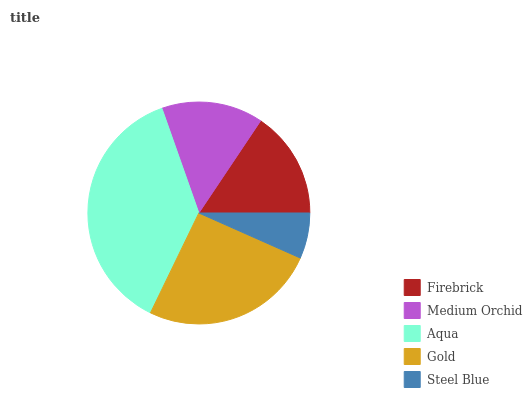Is Steel Blue the minimum?
Answer yes or no. Yes. Is Aqua the maximum?
Answer yes or no. Yes. Is Medium Orchid the minimum?
Answer yes or no. No. Is Medium Orchid the maximum?
Answer yes or no. No. Is Firebrick greater than Medium Orchid?
Answer yes or no. Yes. Is Medium Orchid less than Firebrick?
Answer yes or no. Yes. Is Medium Orchid greater than Firebrick?
Answer yes or no. No. Is Firebrick less than Medium Orchid?
Answer yes or no. No. Is Firebrick the high median?
Answer yes or no. Yes. Is Firebrick the low median?
Answer yes or no. Yes. Is Gold the high median?
Answer yes or no. No. Is Aqua the low median?
Answer yes or no. No. 